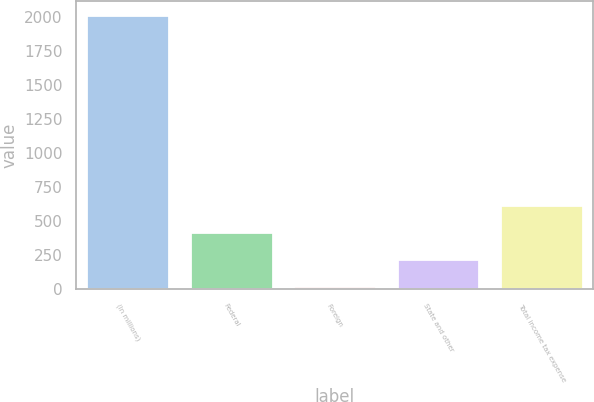Convert chart. <chart><loc_0><loc_0><loc_500><loc_500><bar_chart><fcel>(In millions)<fcel>Federal<fcel>Foreign<fcel>State and other<fcel>Total income tax expense<nl><fcel>2016<fcel>421.04<fcel>22.3<fcel>221.67<fcel>620.41<nl></chart> 